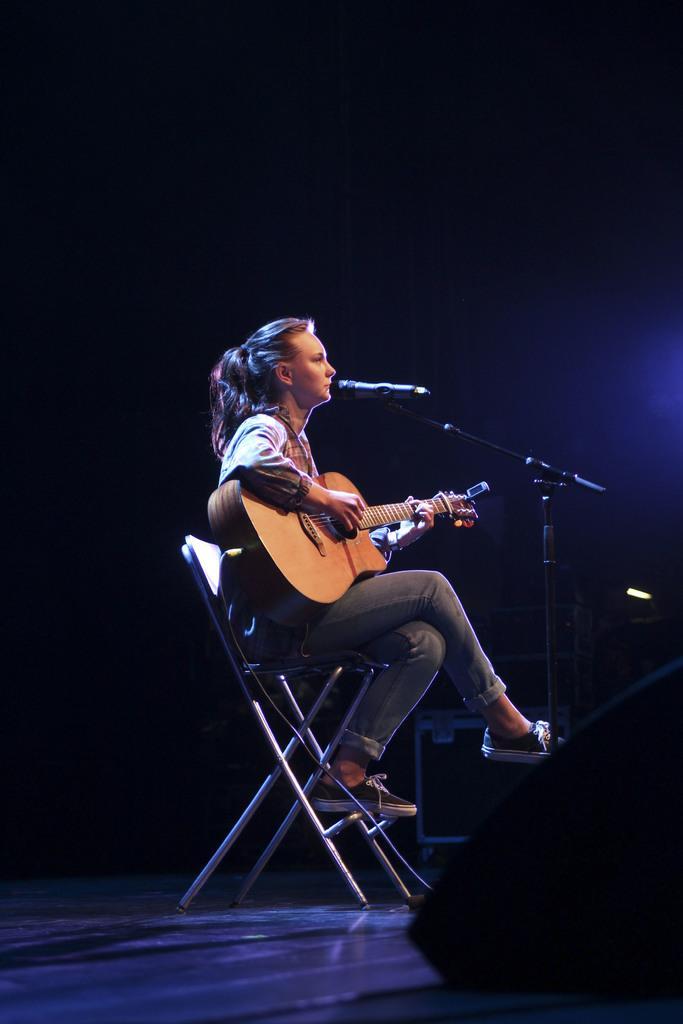Could you give a brief overview of what you see in this image? A woman is sitting in a chair and playing a guitar with a mic in front of her. 